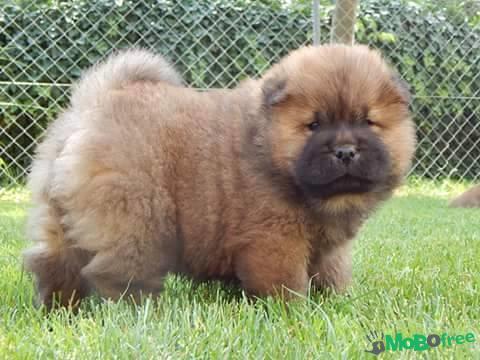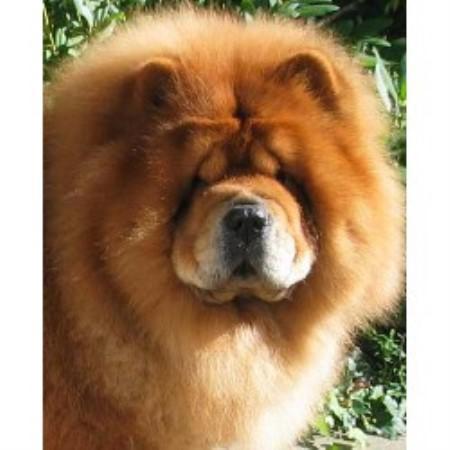The first image is the image on the left, the second image is the image on the right. Given the left and right images, does the statement "There two dogs in total." hold true? Answer yes or no. Yes. The first image is the image on the left, the second image is the image on the right. Evaluate the accuracy of this statement regarding the images: "Each image contains exactly one chow dog, and at least one image shows a dog standing in profile on grass.". Is it true? Answer yes or no. Yes. 